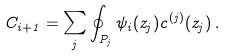<formula> <loc_0><loc_0><loc_500><loc_500>C _ { i + 1 } = \sum _ { j } \oint _ { P _ { j } } \psi _ { i } ( z _ { j } ) c ^ { ( j ) } ( z _ { j } ) \, .</formula> 